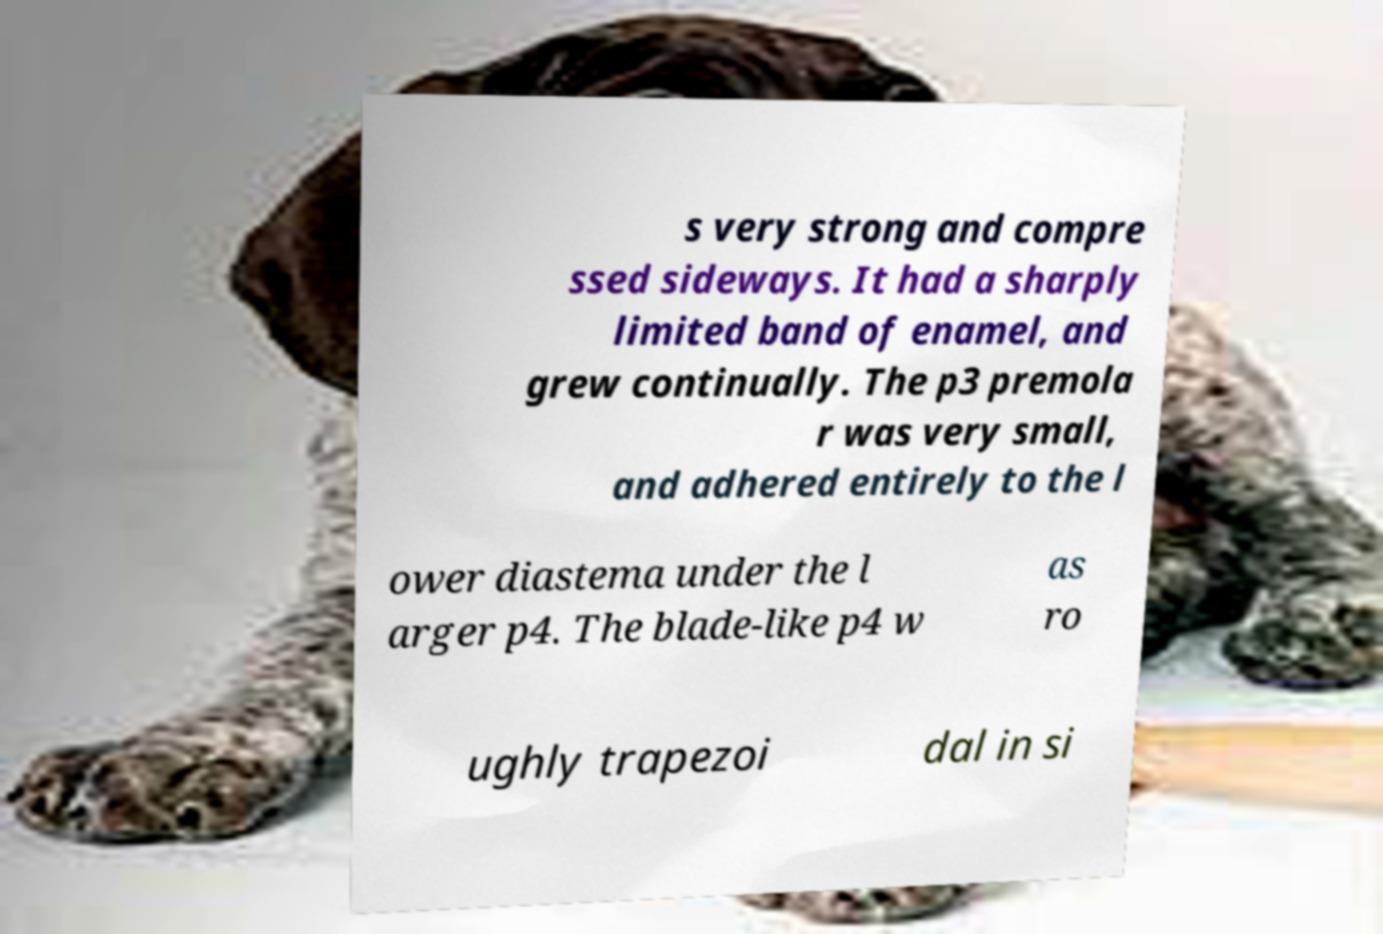Please identify and transcribe the text found in this image. s very strong and compre ssed sideways. It had a sharply limited band of enamel, and grew continually. The p3 premola r was very small, and adhered entirely to the l ower diastema under the l arger p4. The blade-like p4 w as ro ughly trapezoi dal in si 